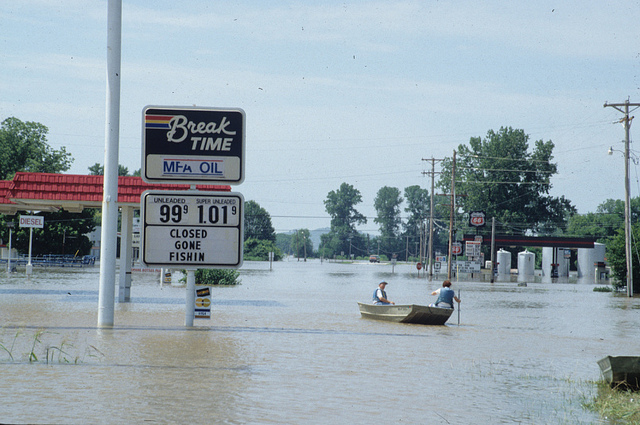<image>What is there only one of when there should be a pair? I am not sure. There could be only one 'oar' when there should be a pair. What type of work is going on ahead? It's not certain which type of work is going on. It could be water rescue, rowing or fishing. What is there only one of when there should be a pair? I don't know what is there only one of when there should be a pair. It can be oars or an oar. What type of work is going on ahead? I don't know what type of work is going on ahead. It can be water rescue, boating, flood rescue, boat, rescue, rowing, or fishing. 